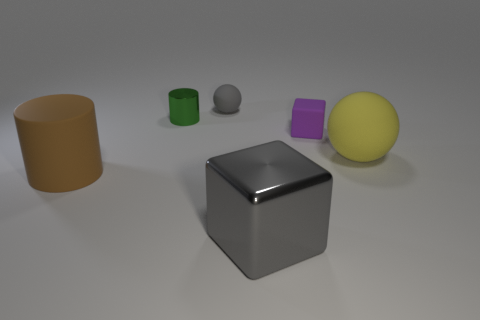Add 3 metallic blocks. How many objects exist? 9 Subtract all balls. How many objects are left? 4 Add 3 cylinders. How many cylinders exist? 5 Subtract 1 purple blocks. How many objects are left? 5 Subtract all large shiny balls. Subtract all cylinders. How many objects are left? 4 Add 5 tiny spheres. How many tiny spheres are left? 6 